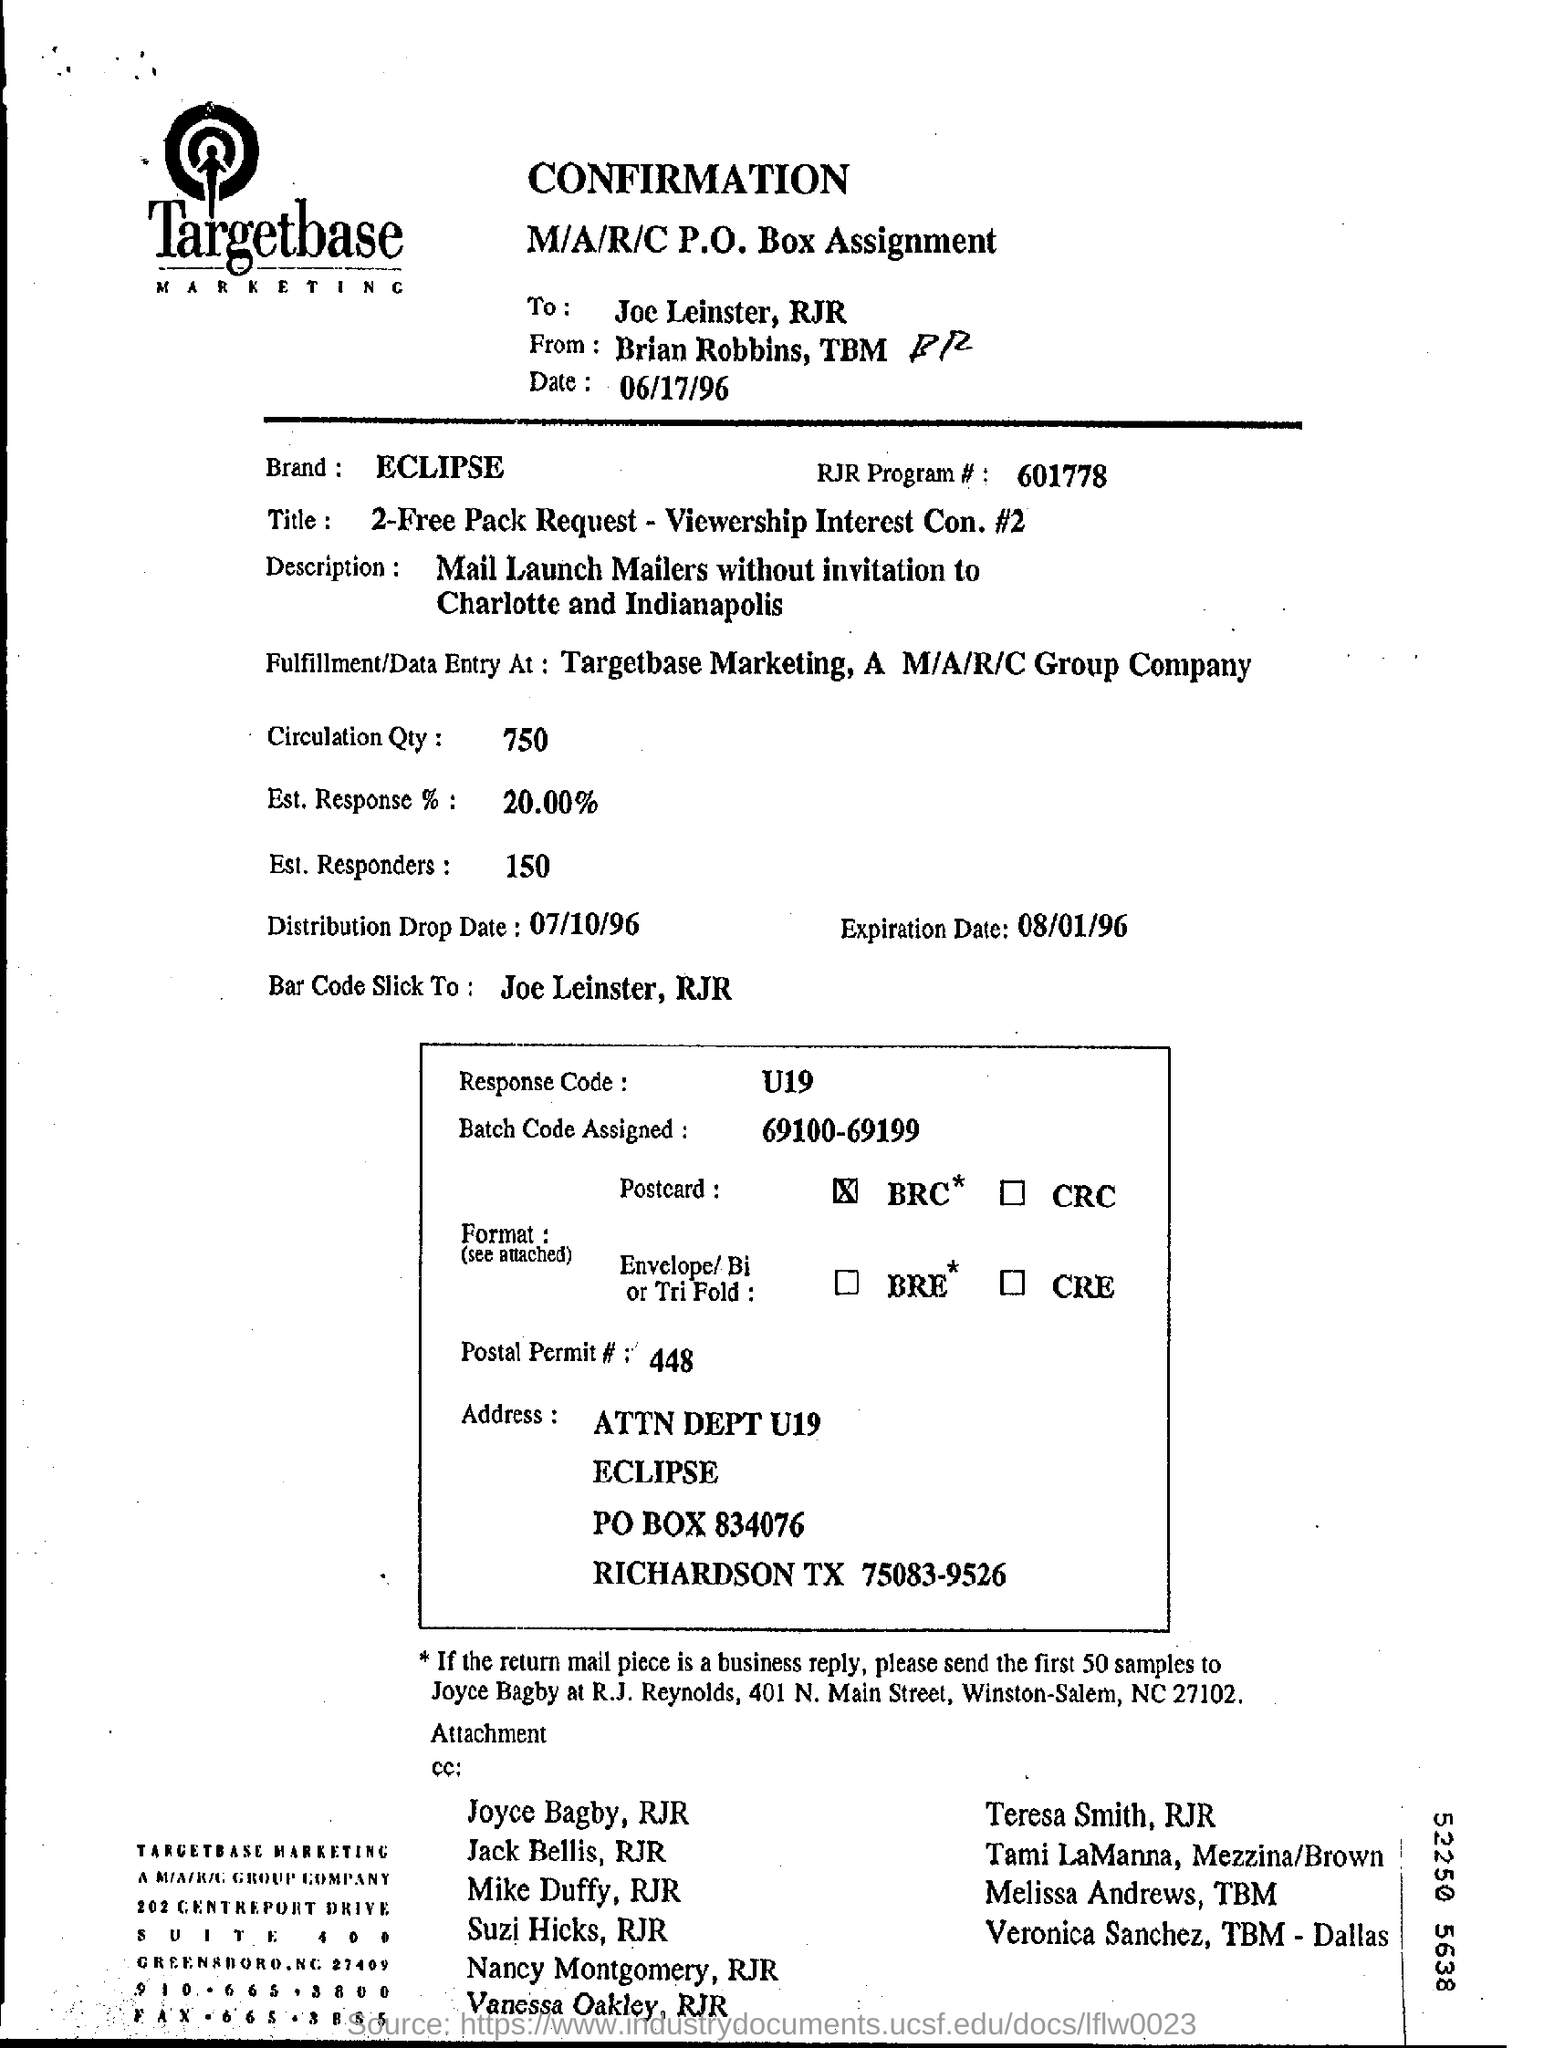Outline some significant characteristics in this image. The estimated response rate is 20.00%. The expiration date is August 1, 1996. Please provide the number RJR program# 601778... Brian Robbins is sending a message for confirmation to Joe Leinster, and requesting confirmation from Brian Robbins to Joe Leinster. What is the code for the response? It is U19.. 